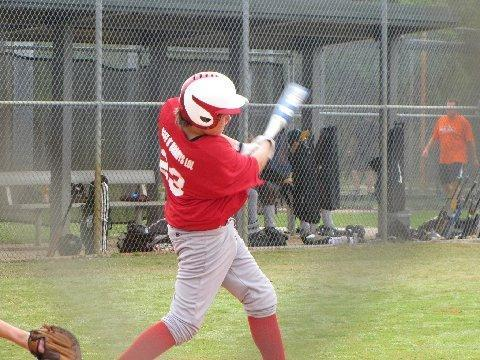Provide a succinct description of the environment in the image. The environment seems to be an outdoor baseball field with green grass, a gray metal fence, and a dugout area. Mention any elements related to baseball equipment found in the image. There is a metal baseball bat, a catcher's mitt, a protective helmet, and bats in the dugout. Comment on the appearance of the fence in the image. The fence is a gray metal, wiremesh structure with tall posts and signs of rust on the pole. How would you describe the quality of this image? The image seems to be of good quality and clear, with some minor blurriness around the swinging bat. Briefly explain the role of the man in orange in the image. The man in an orange shirt and black shorts appears to be walking on the sideline or observing the game. What is the emotional tone of the image based on the actions of the subjects? The emotional tone of the image is intense and focused, as the baseball player is concentrating on hitting the ball, and the man in orange is observing the game. Identify the primary action taking place in the image involving the baseball player. A young man in a red and grey uniform is playing baseball, swinging his bat and hitting the ball. Estimate the number of people that can be identified in this image. There are at least 3 people identified in this image: the baseball player, the man in orange, and the man in a black jacket. Provide a short description of the baseball player's attire in the image. The baseball player is wearing a red jersey, white pants, high red socks, a white and red helmet, and a mitt. What is the color of the baseball player's jersey? The color of the baseball player's jersey is red. What is the sentiment of the image? Positive How does the man in the orange shirt look like? The man is walking and wearing an orange shirt and black shorts. What type of obstacle is in front of the players? Gray metal fence Count the number of people in the image. 3 Can you spot the referee wearing a black and white striped shirt? He's standing close to the baseball players. No, it's not mentioned in the image. Find a person who is not involved in the game. Man in orange shirt walking Which player is wearing a mitt? Person standing behind the batter What kind of equipment is hanging on the fence? A baseball bat What color are the pants that the baseball player is wearing? White What's the color of the man's shirt who is walking in the background? Orange Describe the main action happening in the image. A young man playing baseball is swinging a bat. Identify any text or letters visible in the image. No text visible Which captions describe the same object in the image? baseball player in red and grey uniform; a baseball player wearing a red uniform; man in a red tshirt List the different objects in the image. Young man playing baseball, metal baseball bat, man in orange and white shirt, gray metal fence, green grass, rust on the pole, red socks, catchers mitt, white and red helmets, man in black jacket, wiremesh fence, tall post on the fence, bats in the dugout, blurry bat, field of green grass. What are the red items found near the bottom of the image? Red socks Describe the condition of the pole near the fence. There is rust on the pole. Estimate the image quality on a scale of 1 to 10. 7 What colors and patterns are on the baseball player's uniform? The uniform is red and grey, with a red jersey and white pants. What color is the batter's helmet? White and red What kind of field is the game being played on? Field of green grass What type of fencing is being used in the image? Wiremesh fence 